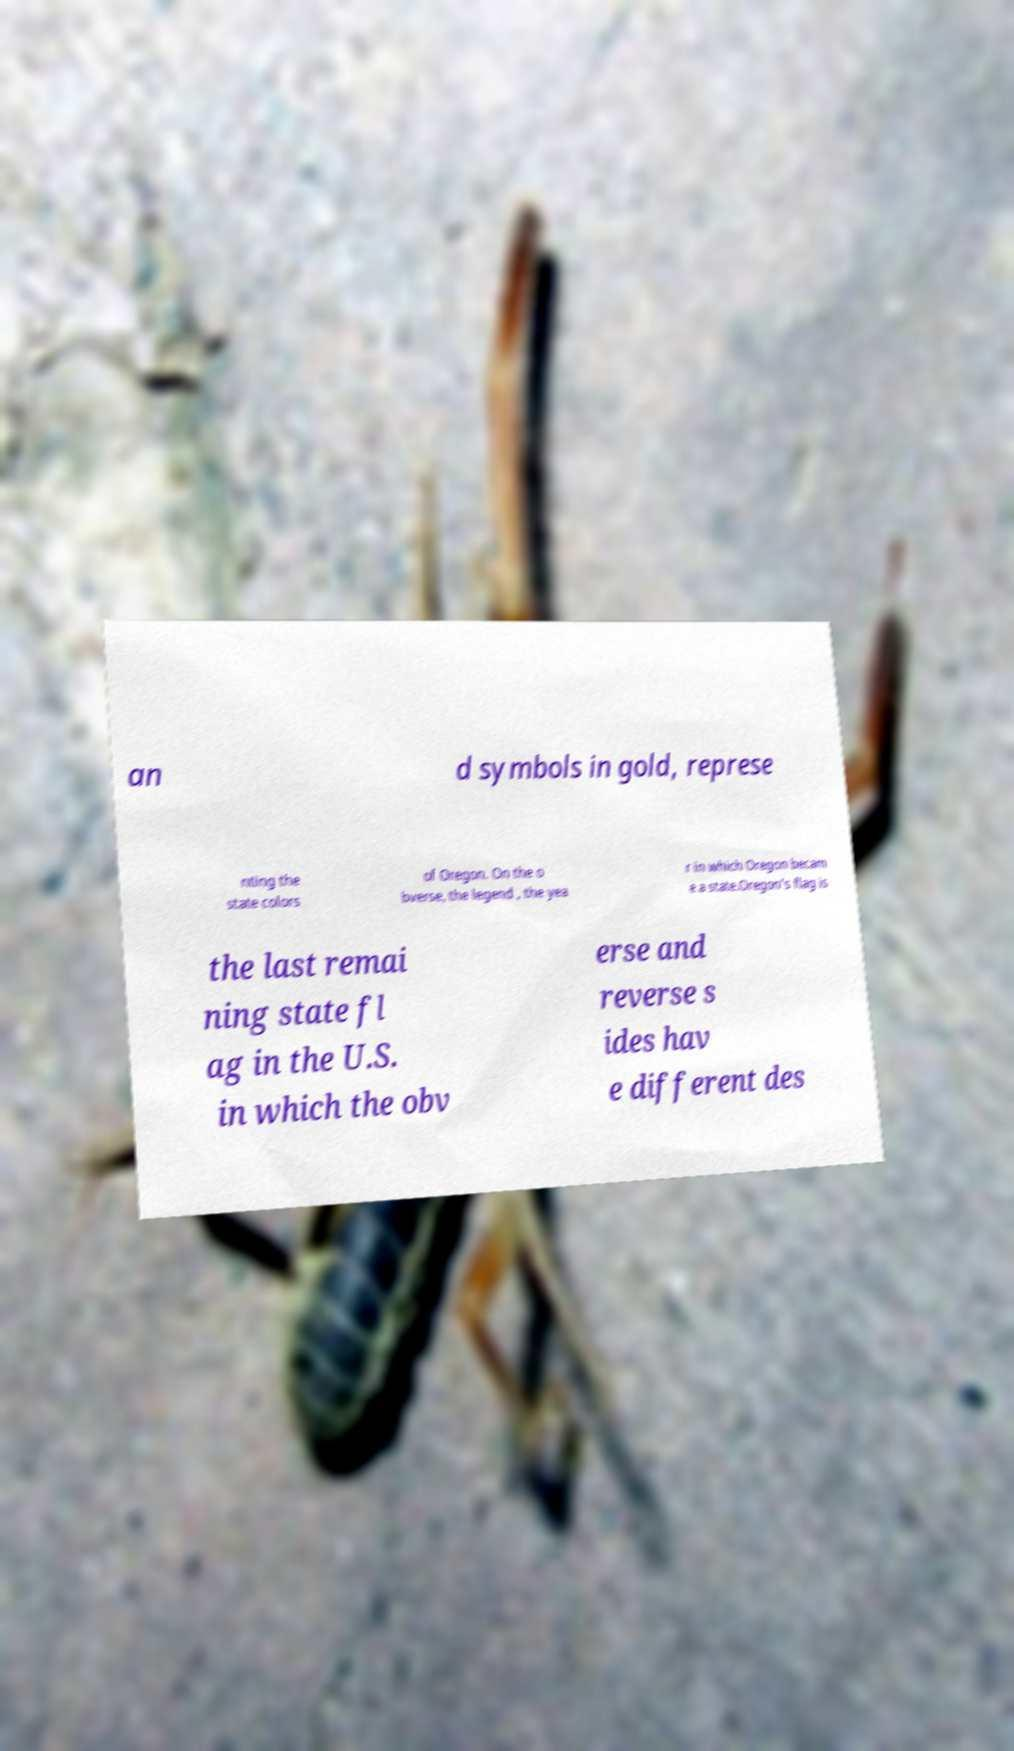Could you extract and type out the text from this image? an d symbols in gold, represe nting the state colors of Oregon. On the o bverse, the legend , the yea r in which Oregon becam e a state.Oregon's flag is the last remai ning state fl ag in the U.S. in which the obv erse and reverse s ides hav e different des 